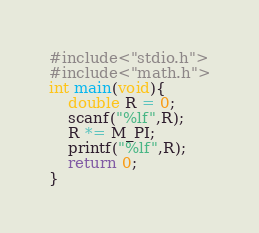<code> <loc_0><loc_0><loc_500><loc_500><_C_>#include<"stdio.h">
#include<"math.h">
int main(void){
	double R = 0; 
    scanf("%lf",R);
  	R *= M_PI;
    printf("%lf",R);
	return 0;
}</code> 